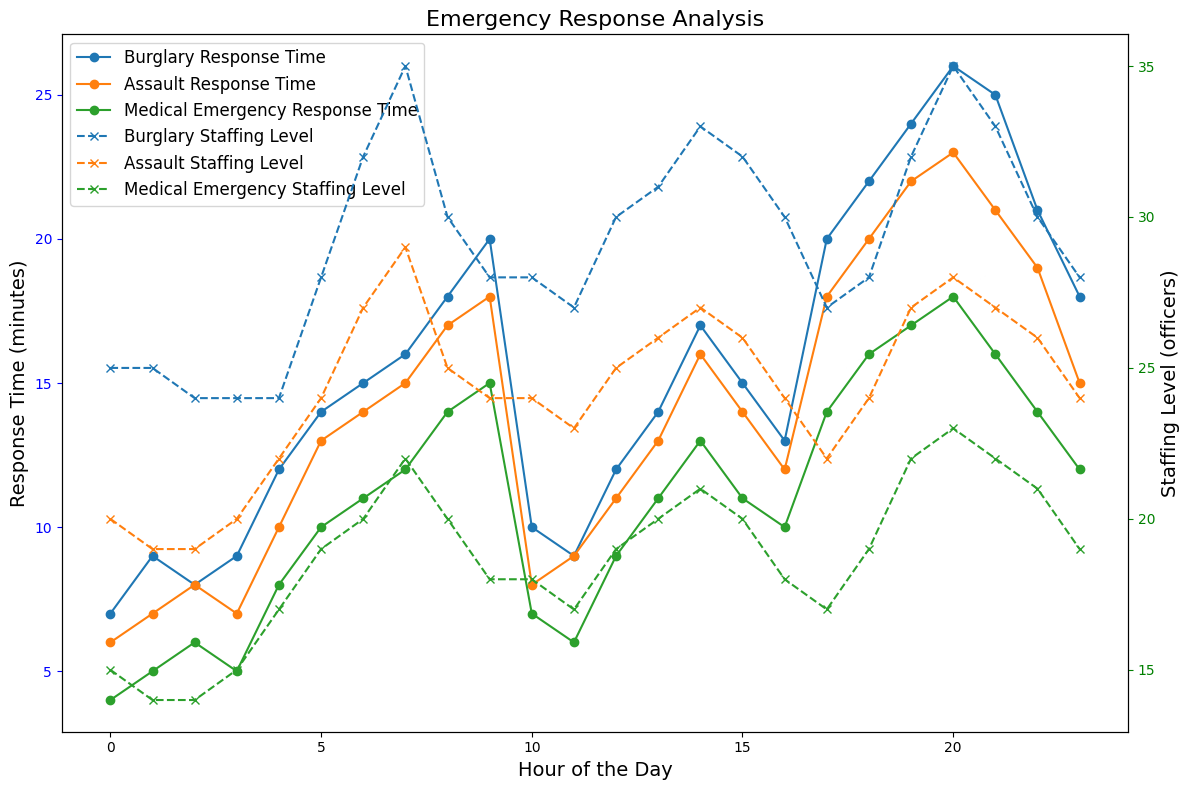What's the difference in response time for Burglary incidents between hour 6 and hour 16? At hour 6, the response time for Burglary is 15 minutes. At hour 16, the response time for Burglary is 13 minutes. The difference is 15 - 13 = 2 minutes.
Answer: 2 minutes Which type of emergency has the highest response time at hour 20? At hour 20, the response times are: Burglary (26 minutes), Assault (23 minutes), Medical Emergency (18 minutes). The highest response time is for Burglary at 26 minutes.
Answer: Burglary During peak hours, which emergency type generally has the highest staffing levels? Reviewing the staffing levels for peak hours, Burglary often has staffing levels between 30-35 officers, Assault between 20-29 officers, and Medical Emergency between 17-23 officers. Burglary tends to have the highest staffing levels.
Answer: Burglary What is the average response time for Medical Emergencies during non-peak hours? Non-peak hours for Medical Emergencies are: hour 0 (4 minutes), hour 1 (5 minutes), hour 2 (6 minutes), hour 3 (5 minutes), hour 10 (7 minutes), hour 11 (6 minutes), hour 23 (12 minutes). The total response time is 4 + 5 + 6 + 5 + 7 + 6 + 12 = 45 minutes. There are 7 non-peak hours, so the average is 45 / 7 ≈ 6.43 minutes.
Answer: 6.43 minutes Compare the staffing levels for Medical Emergencies at hour 9 to Assaults at the same hour. Which has more officers? At hour 9, Medical Emergencies have a staffing level of 18 officers. Assaults have a staffing level of 24 officers at hour 9. Therefore, Assaults have more officers.
Answer: Assaults What is the difference in response time during peak and non-peak hours for Assault emergencies? During non-peak hours, the response times for Assault are: hour 0 (6 minutes), hour 1 (7 minutes), hour 2 (8 minutes), hour 3 (7 minutes), hour 10 (8 minutes), hour 11 (9 minutes), hour 23 (15 minutes). Total is 6 + 7 + 8 + 7 + 8 + 9 + 15 = 60 minutes over 7 hours, so the average is 60/7 ≈ 8.57 minutes. During peak hours, the response times are: hour 4 (10 minutes), hour 5 (13 minutes), hour 6 (14 minutes), hour 7 (15 minutes), hour 8 (17 minutes), hour 9 (18 minutes), hour 12 (11 minutes), hour 13 (13 minutes), hour 14 (16 minutes), hour 15 (14 minutes), hour 16 (12 minutes), hour 17 (18 minutes), hour 18 (20 minutes), hour 19 (22 minutes), hour 20 (23 minutes), hour 21 (21 minutes), hour 22 (19 minutes). Total is 18 + 13 + 14 + 15 + 17 + 18 + 11 + 13 + 16 + 14 + 12 + 18 + 20 + 22 + 23 + 21 + 19 = 286 minutes over 17 hours, so the average is 286/17 ≈ 16.82 minutes. The difference is 16.82 - 8.57 ≈ 8.25 minutes.
Answer: 8.25 minutes How does the response time for Medical Emergencies at hour 18 compare to the staffing level at the same hour? At hour 18, the response time for Medical Emergencies is 16 minutes. At the same hour, the staffing level is 19 officers. Therefore, the response time is 16 minutes and the staffing level is 19 officers.
Answer: 16 minutes, 19 officers What is the general trend in response times for Burglary calls from hours 4 to 9? From hour 4 to hour 9, the response times for Burglary increase: hour 4 (12 minutes), hour 5 (14 minutes), hour 6 (15 minutes), hour 7 (16 minutes), hour 8 (18 minutes), hour 9 (20 minutes). The trend shows a general increase in response times during this period.
Answer: General increase In terms of staffing, which hour of the day has the highest level for Burglary? Examining the staffing levels for the entire day, the highest level for Burglary is at hour 7 with 35 officers.
Answer: Hour 7 What are the peak and non-peak hours for Medical Emergency response times? Peak hours for Medical Emergencies are: 4, 5, 6, 7, 8, 9, 12, 13, 14, 15, 16, 17, 18, 19, 20, 21, 22. Non-peak hours are: 0, 1, 2, 3, 10, 11, 23. These are identified by the 'Peak Hours' column.
Answer: Peak: 4-9, 12-22; Non-peak: 0-3, 10-11, 23 